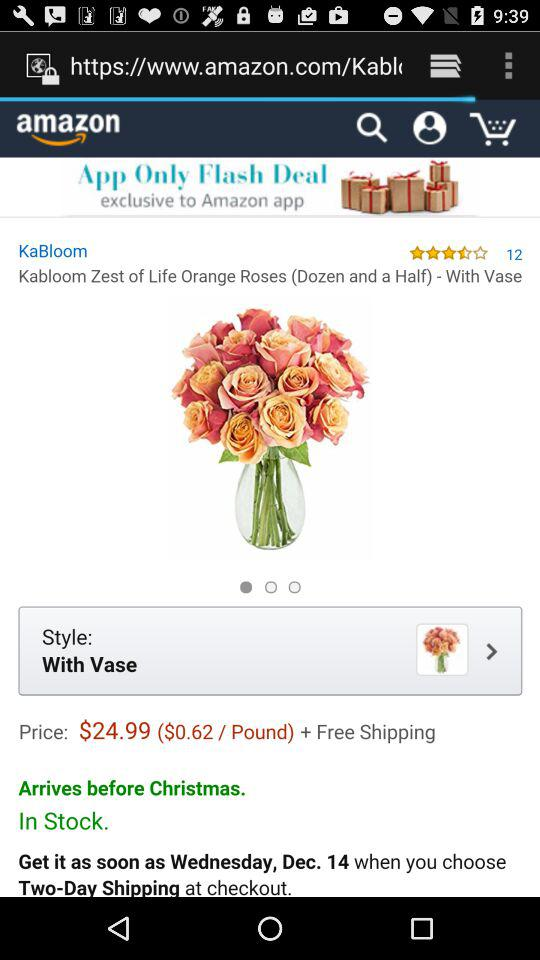What is the name of the application? The name of the application is "amazon". 